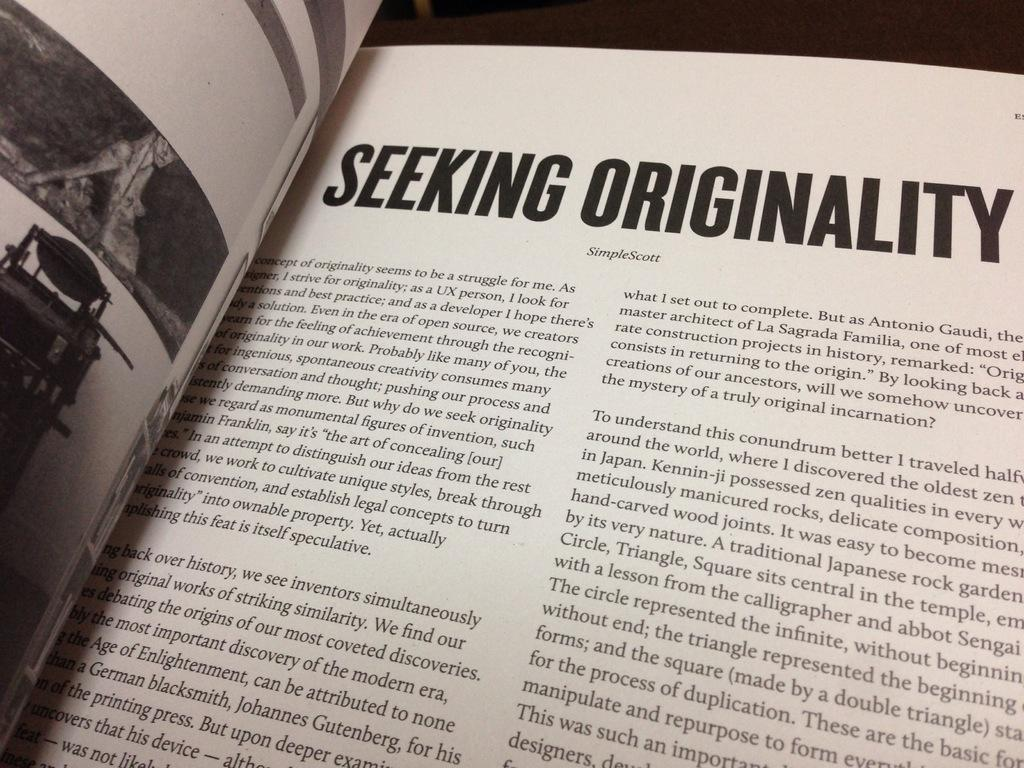What is the main object in the picture? There is a book in the picture. How is the book positioned in the image? The book is open. What else can be seen in the picture besides the book? There are papers in the picture. Can you describe the content of the papers? The papers contain black and white pictures and writing. How many pets are jumping in the picture? There are no pets or jumping depicted in the image; it features a book and papers with writing and black and white pictures. 